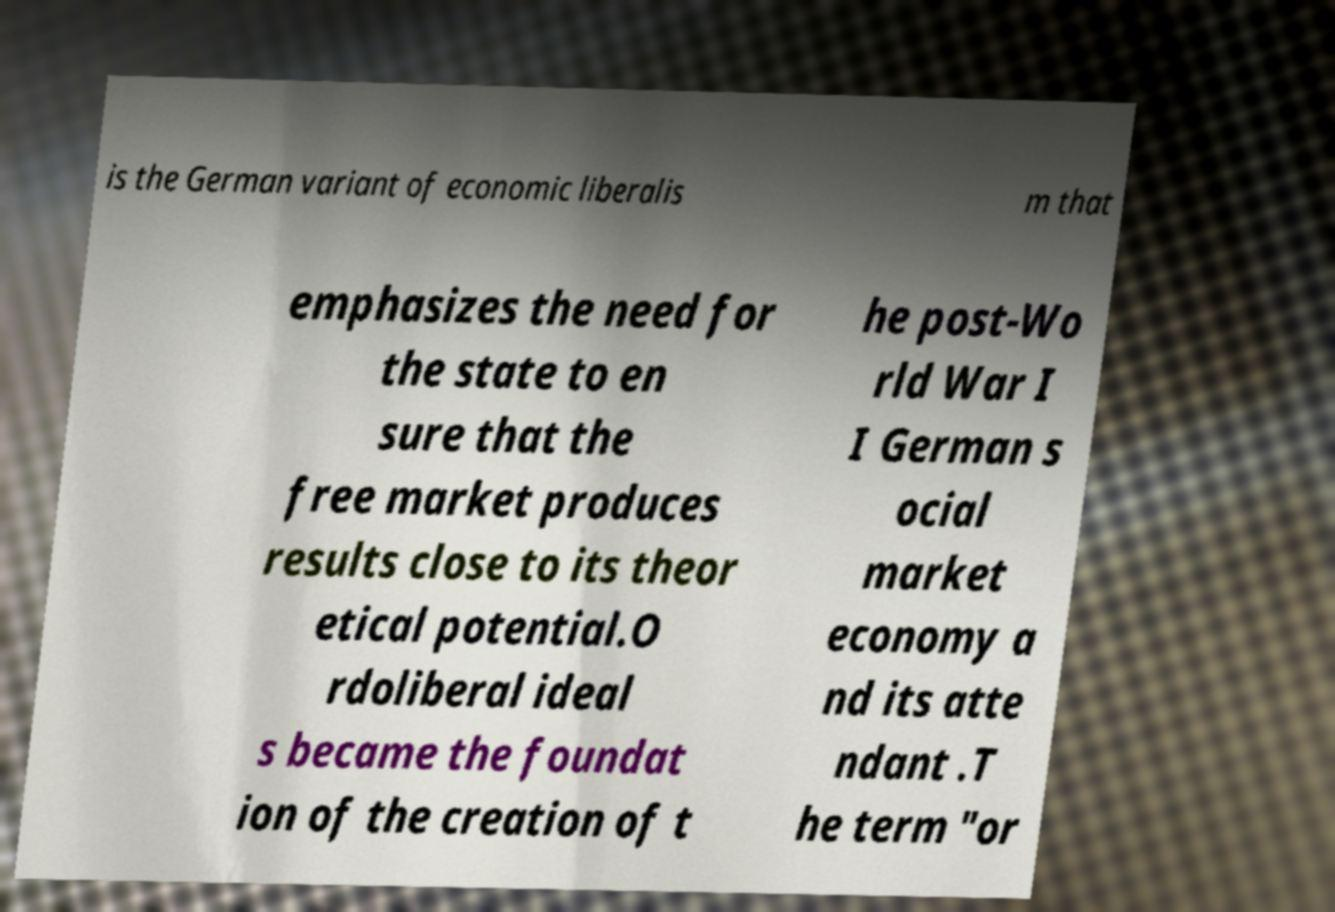Please identify and transcribe the text found in this image. is the German variant of economic liberalis m that emphasizes the need for the state to en sure that the free market produces results close to its theor etical potential.O rdoliberal ideal s became the foundat ion of the creation of t he post-Wo rld War I I German s ocial market economy a nd its atte ndant .T he term "or 